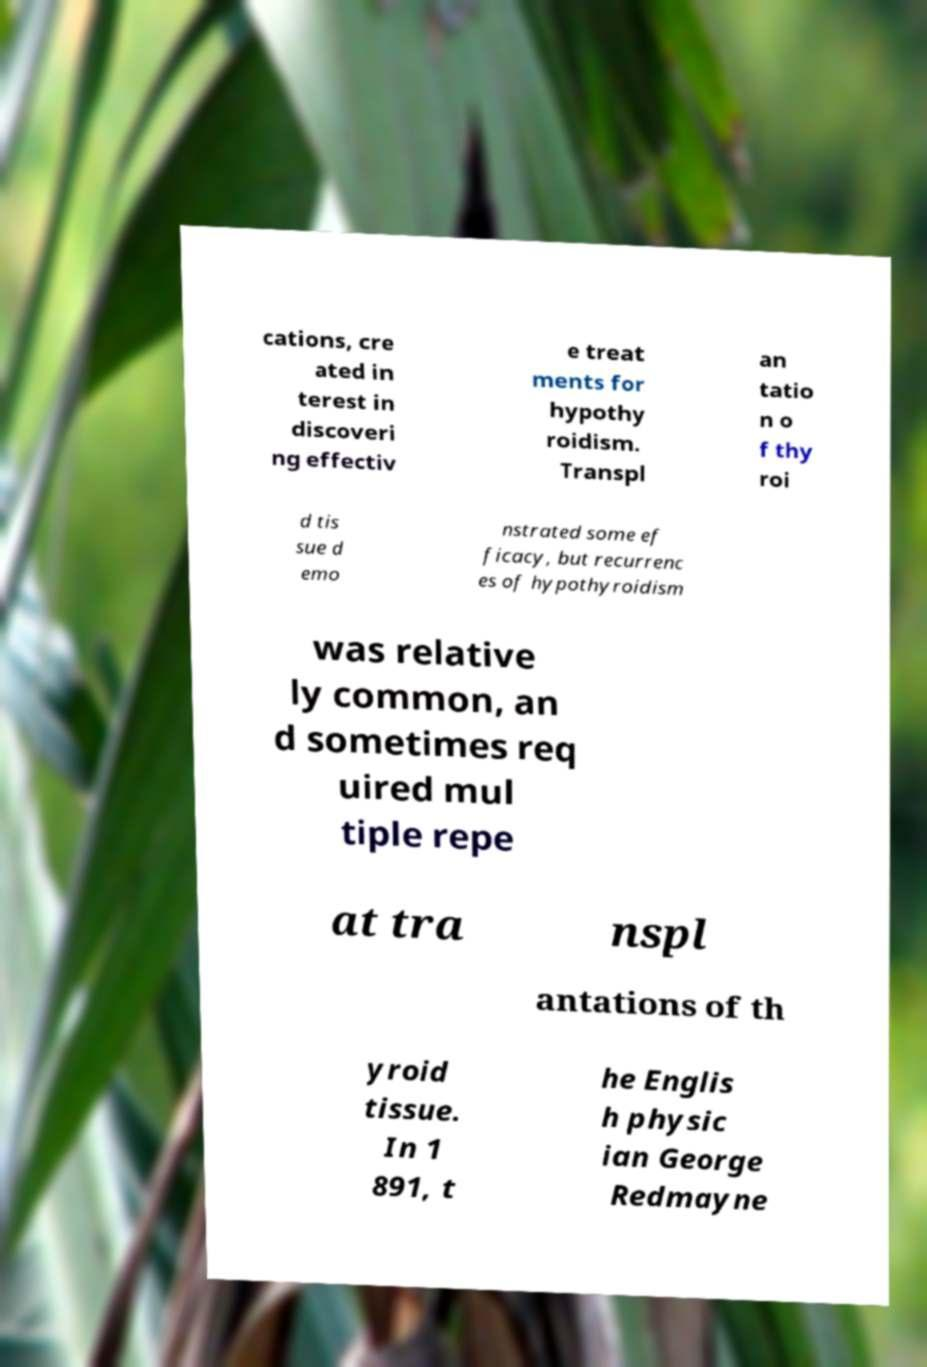For documentation purposes, I need the text within this image transcribed. Could you provide that? cations, cre ated in terest in discoveri ng effectiv e treat ments for hypothy roidism. Transpl an tatio n o f thy roi d tis sue d emo nstrated some ef ficacy, but recurrenc es of hypothyroidism was relative ly common, an d sometimes req uired mul tiple repe at tra nspl antations of th yroid tissue. In 1 891, t he Englis h physic ian George Redmayne 